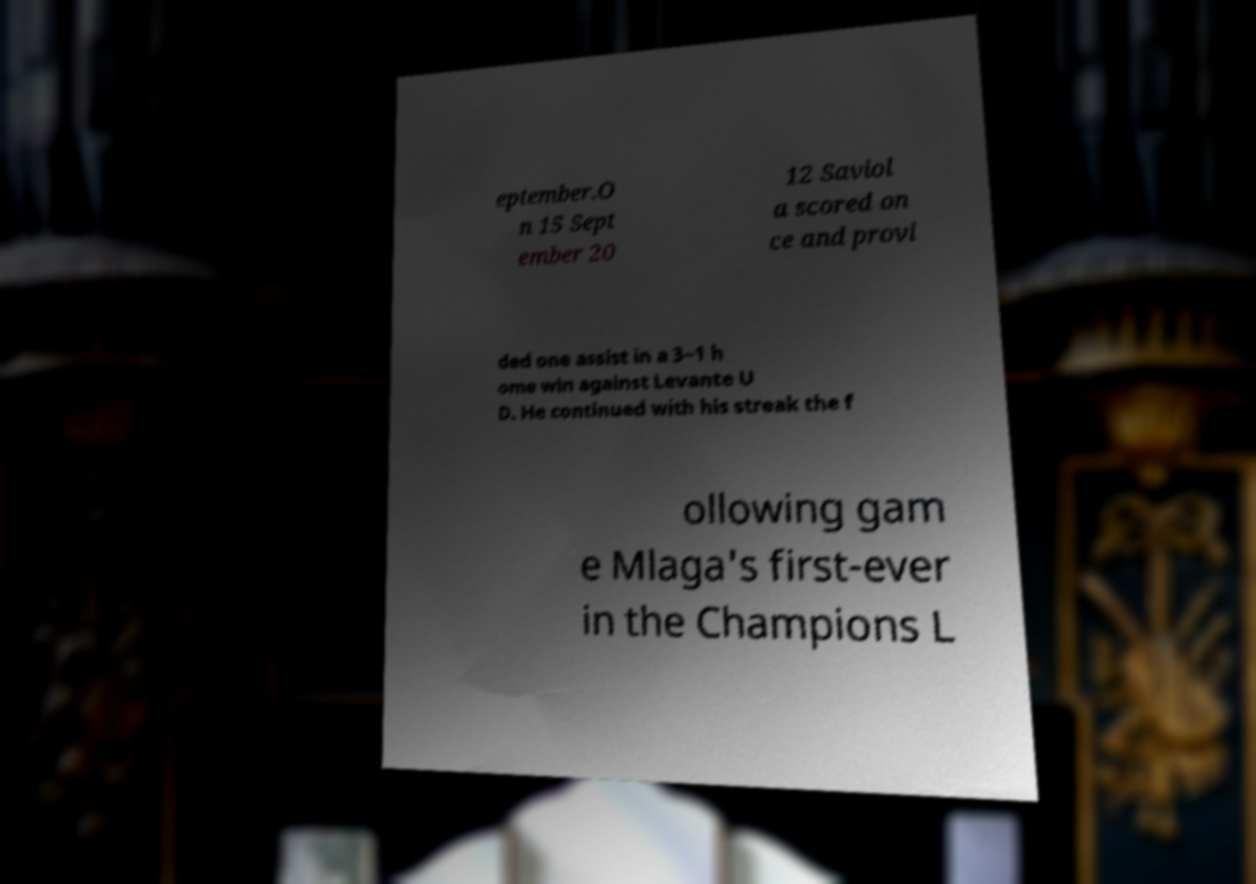Please read and relay the text visible in this image. What does it say? eptember.O n 15 Sept ember 20 12 Saviol a scored on ce and provi ded one assist in a 3−1 h ome win against Levante U D. He continued with his streak the f ollowing gam e Mlaga's first-ever in the Champions L 